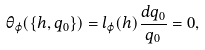Convert formula to latex. <formula><loc_0><loc_0><loc_500><loc_500>\theta _ { \varphi } ( \{ h , q _ { 0 } \} ) = l _ { \varphi } ( h ) \frac { d q _ { 0 } } { q _ { 0 } } = 0 ,</formula> 